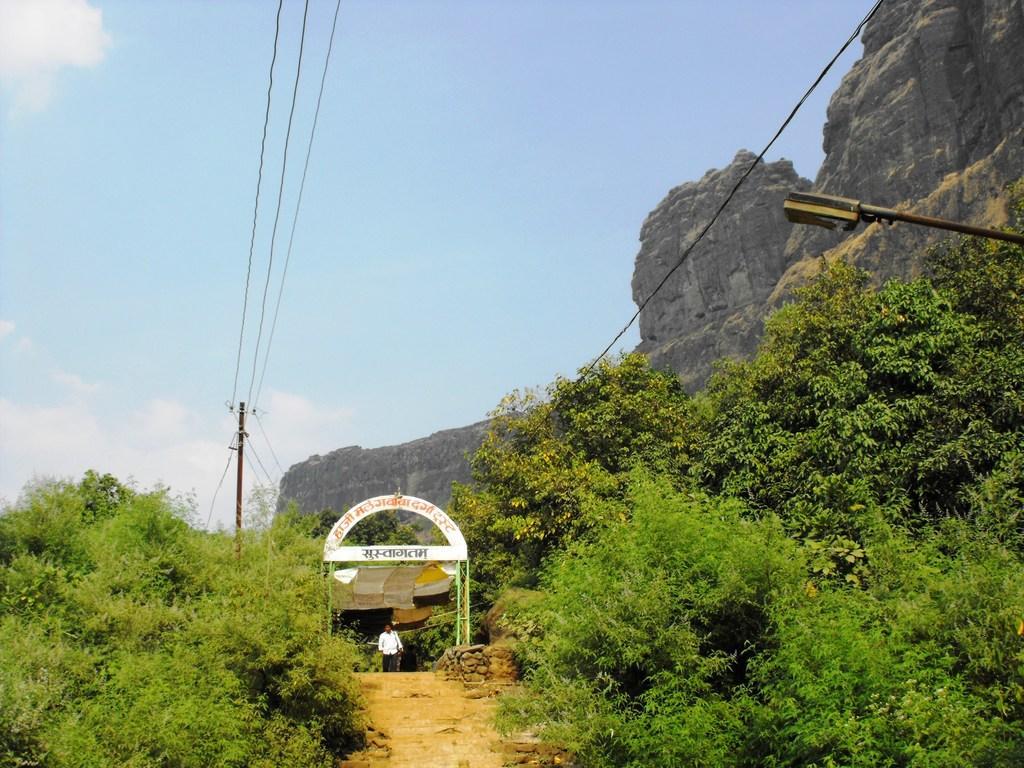In one or two sentences, can you explain what this image depicts? In this image I see the trees and I see the boards over here on which there are words written and I see a person over here and I see the path and I see the poles and wires. In the background I see the sky which is clear and I see the rocky mountains. 